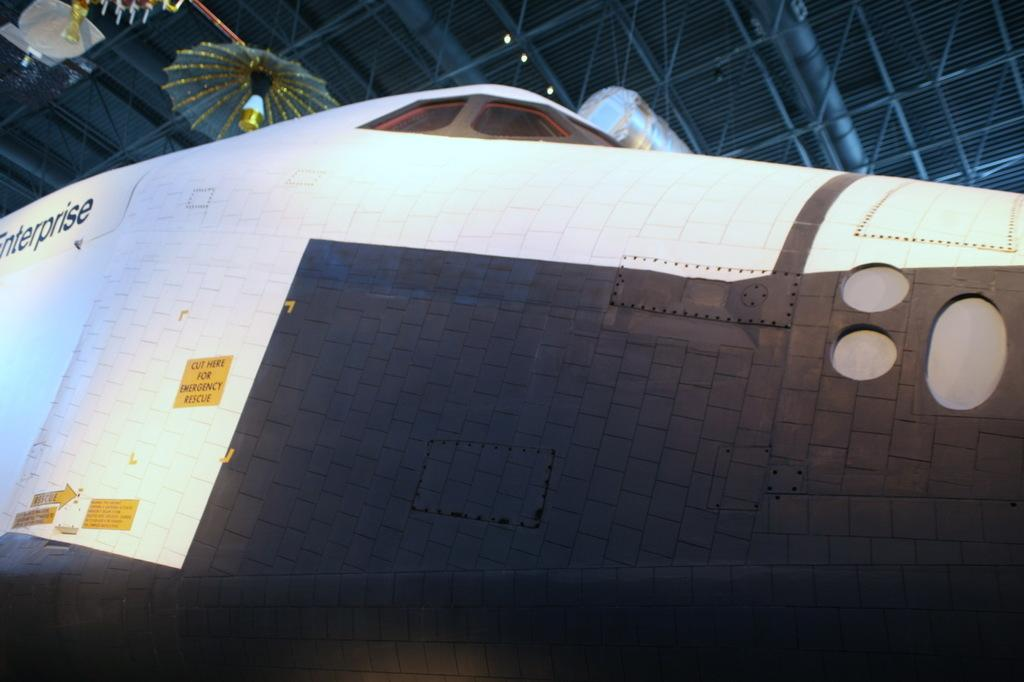What is the main subject of the picture? The main subject of the picture is an airplane. Are there any decorations or markings on the airplane? Yes, the airplane has stickers on it. What can be seen in the background of the picture? There is an umbrella on a roof in the background of the picture. Can you tell me how many houses are visible in the image? There are no houses visible in the image; it features an airplane with stickers and an umbrella on a roof in the background. What type of smoke can be seen coming from the airplane in the image? There is no smoke coming from the airplane in the image. 